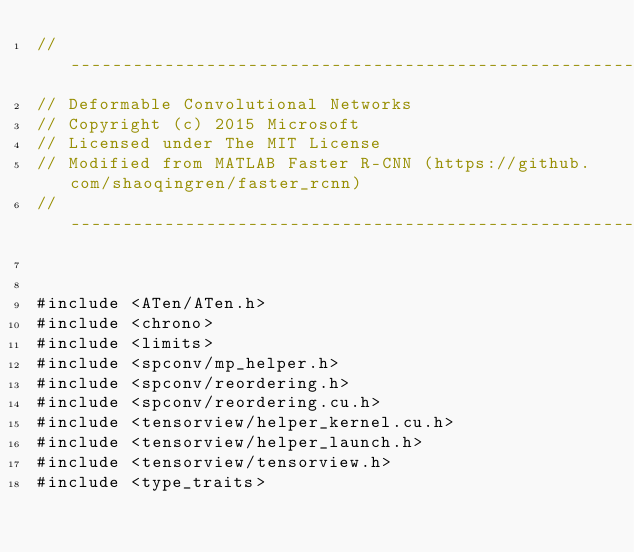<code> <loc_0><loc_0><loc_500><loc_500><_Cuda_>// ------------------------------------------------------------------
// Deformable Convolutional Networks
// Copyright (c) 2015 Microsoft
// Licensed under The MIT License
// Modified from MATLAB Faster R-CNN (https://github.com/shaoqingren/faster_rcnn)
// ------------------------------------------------------------------


#include <ATen/ATen.h>
#include <chrono>
#include <limits>
#include <spconv/mp_helper.h>
#include <spconv/reordering.h>
#include <spconv/reordering.cu.h>
#include <tensorview/helper_kernel.cu.h>
#include <tensorview/helper_launch.h>
#include <tensorview/tensorview.h>
#include <type_traits></code> 